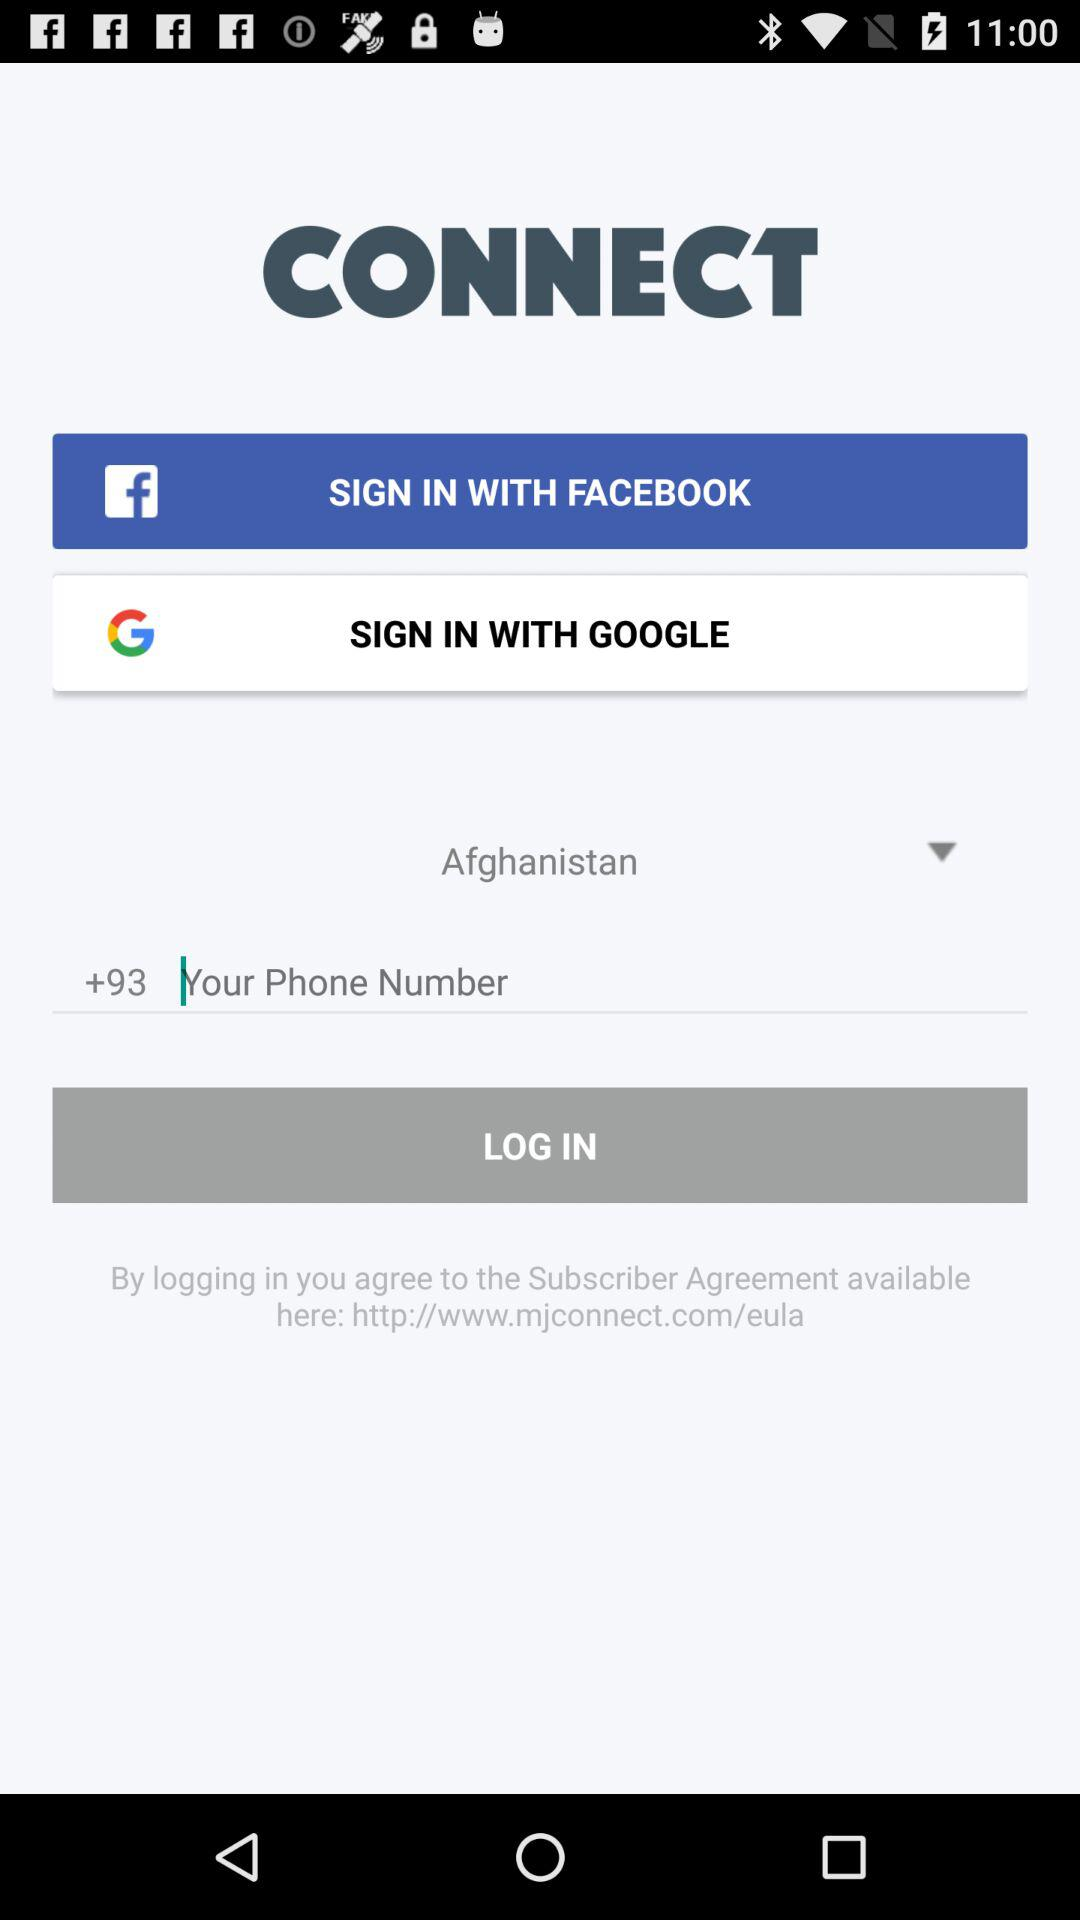What applications can we use to sign in? The applications are "Facebook" and "Google". 